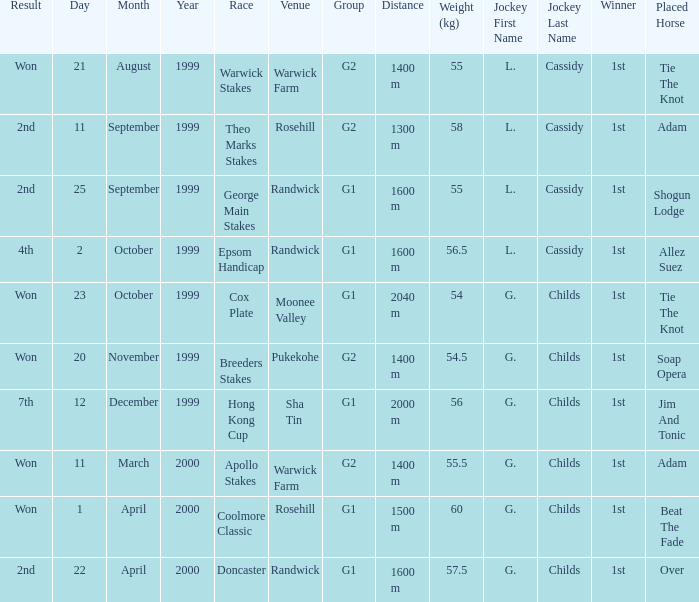List the weight for 56 kilograms. 2000 m. 